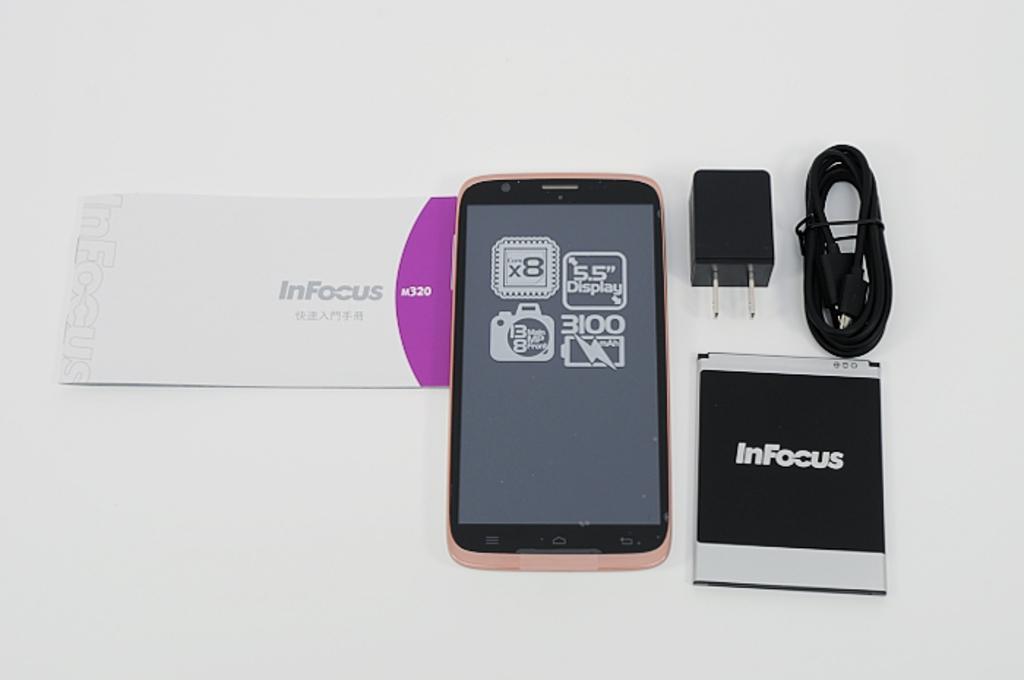What is the display size?
Your answer should be compact. 5.5. What brand phone is this?
Ensure brevity in your answer.  Infocus. 